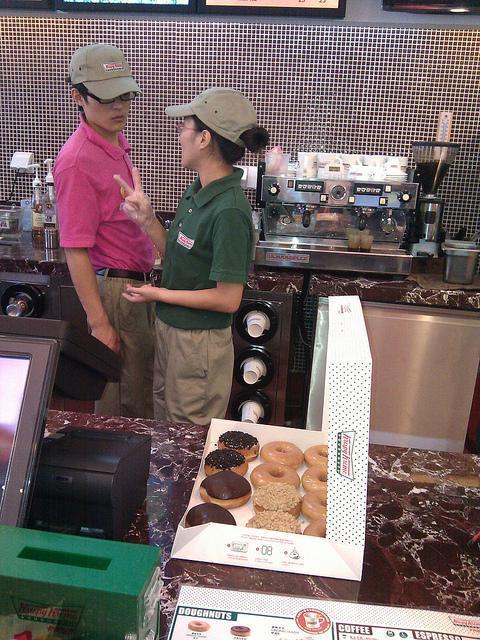How many people are in the photo?
Give a very brief answer. 2. How many people are there?
Give a very brief answer. 2. 